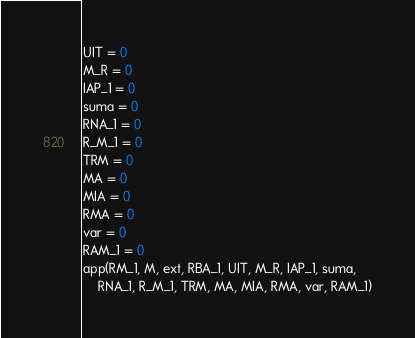<code> <loc_0><loc_0><loc_500><loc_500><_Python_>UIT = 0
M_R = 0
IAP_1 = 0
suma = 0
RNA_1 = 0
R_M_1 = 0
TRM = 0
MA = 0
MIA = 0
RMA = 0
var = 0
RAM_1 = 0
app(RM_1, M, ext, RBA_1, UIT, M_R, IAP_1, suma,
    RNA_1, R_M_1, TRM, MA, MIA, RMA, var, RAM_1)
</code> 